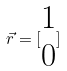<formula> <loc_0><loc_0><loc_500><loc_500>\vec { r } = [ \begin{matrix} 1 \\ 0 \end{matrix} ]</formula> 